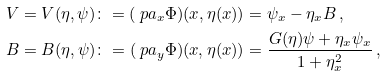<formula> <loc_0><loc_0><loc_500><loc_500>& V = V ( \eta , \psi ) \colon = ( \ p a _ { x } \Phi ) ( x , \eta ( x ) ) = \psi _ { x } - \eta _ { x } B \, , \\ & B = B ( \eta , \psi ) \colon = ( \ p a _ { y } \Phi ) ( x , \eta ( x ) ) = \frac { G ( \eta ) \psi + \eta _ { x } \psi _ { x } } { 1 + \eta _ { x } ^ { 2 } } \, ,</formula> 